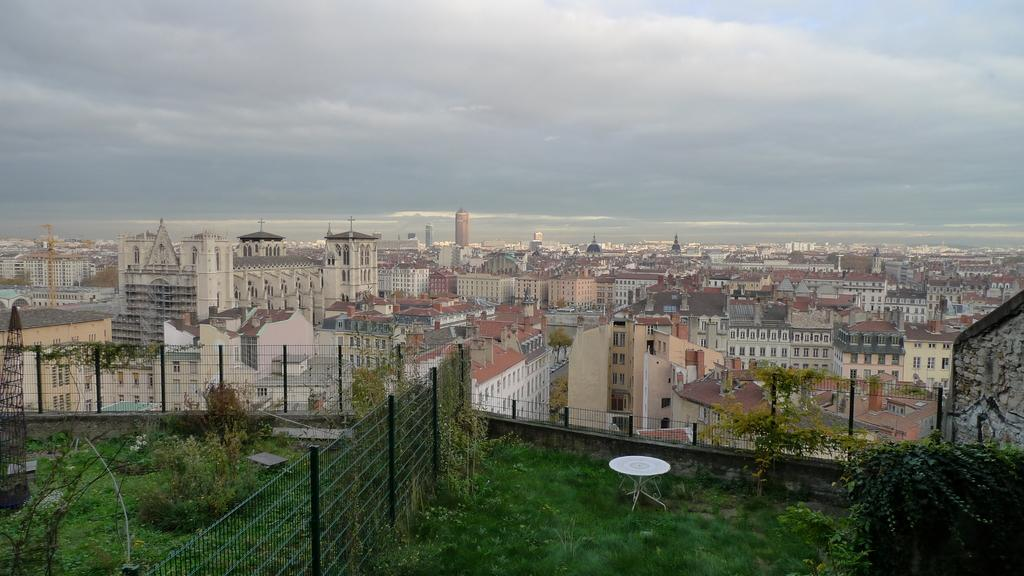What type of living organisms can be seen in the image? Plants can be seen in the image. What is located beside the plants? There is a fence beside the plants. How would you describe the ground in the image? The ground appears to be covered in greenery. What can be seen in the distance in the image? There are buildings in the background of the image. What type of wax is being used to create the cap for the feast in the image? There is no wax, cap, or feast present in the image. 